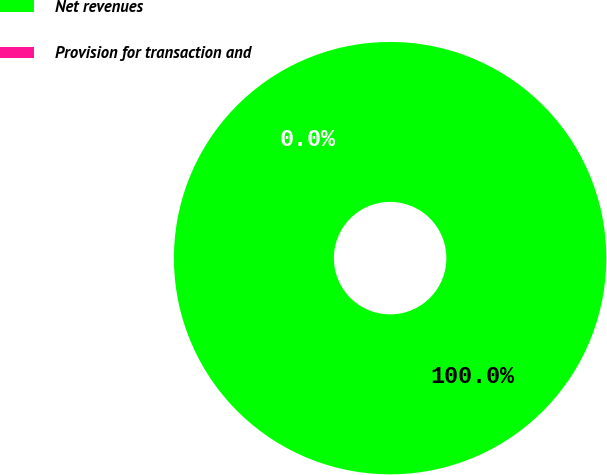Convert chart. <chart><loc_0><loc_0><loc_500><loc_500><pie_chart><fcel>Net revenues<fcel>Provision for transaction and<nl><fcel>100.0%<fcel>0.0%<nl></chart> 